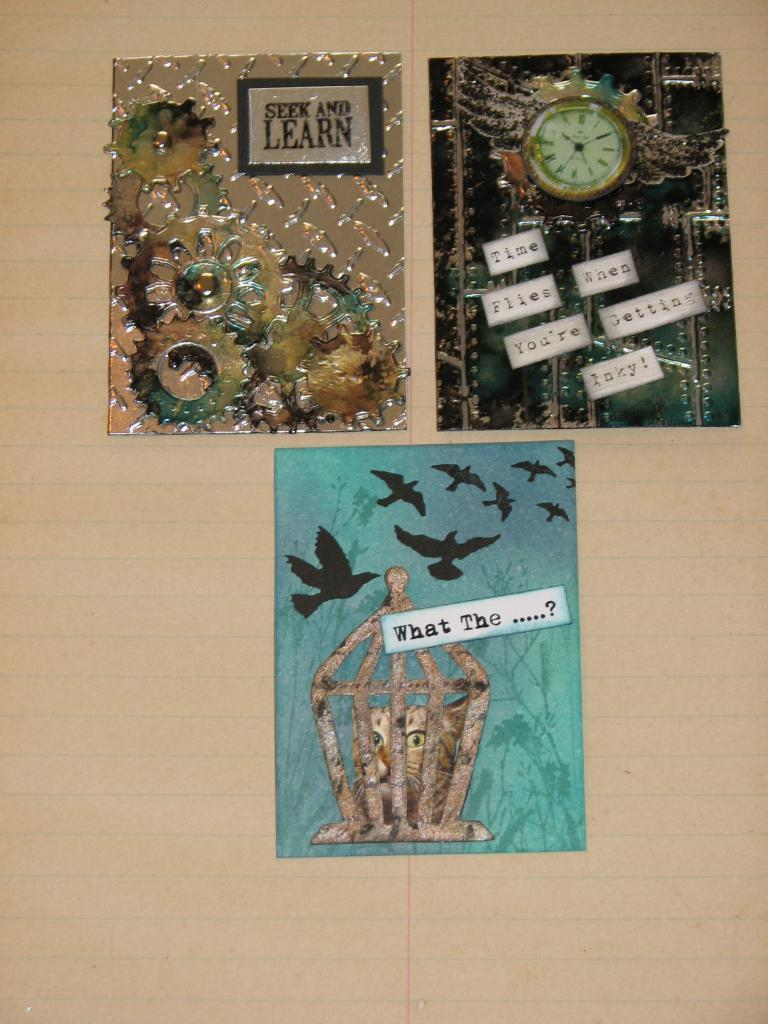<image>
Write a terse but informative summary of the picture. the word learn is on the item next to the clock 